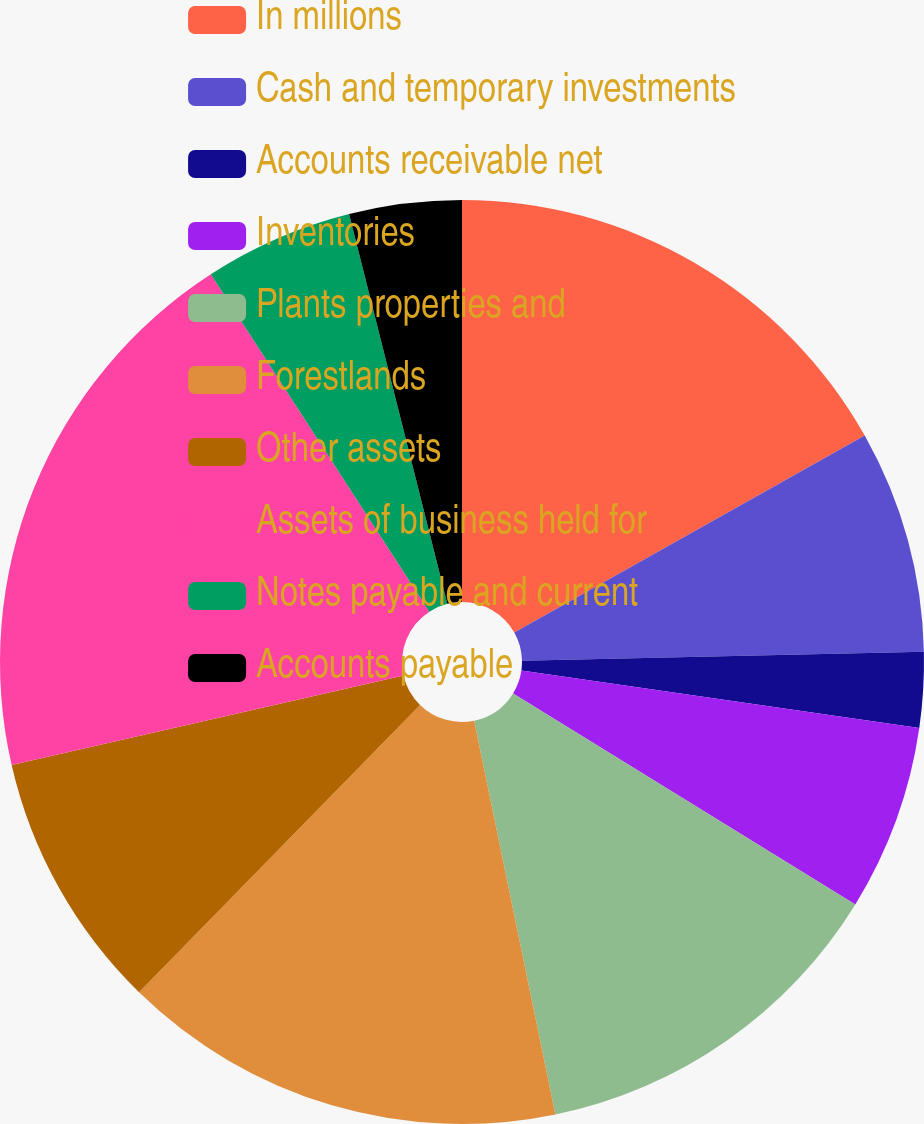<chart> <loc_0><loc_0><loc_500><loc_500><pie_chart><fcel>In millions<fcel>Cash and temporary investments<fcel>Accounts receivable net<fcel>Inventories<fcel>Plants properties and<fcel>Forestlands<fcel>Other assets<fcel>Assets of business held for<fcel>Notes payable and current<fcel>Accounts payable<nl><fcel>16.85%<fcel>7.8%<fcel>2.63%<fcel>6.51%<fcel>12.97%<fcel>15.56%<fcel>9.1%<fcel>19.43%<fcel>5.22%<fcel>3.93%<nl></chart> 